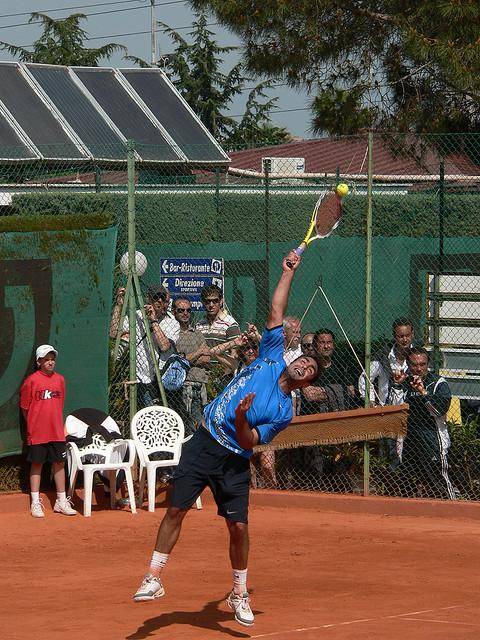What powers the lights here? solar 